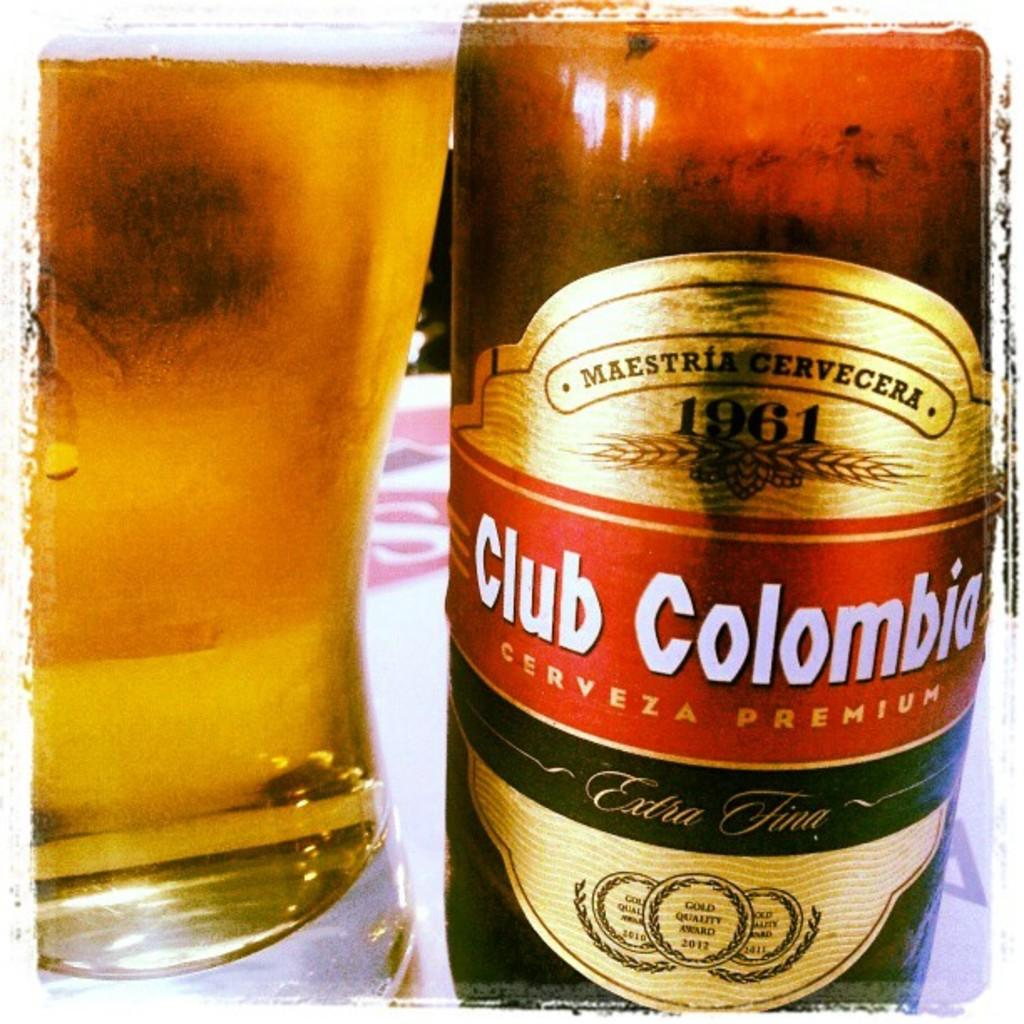<image>
Present a compact description of the photo's key features. bottle of club colombia to the right of full glass 